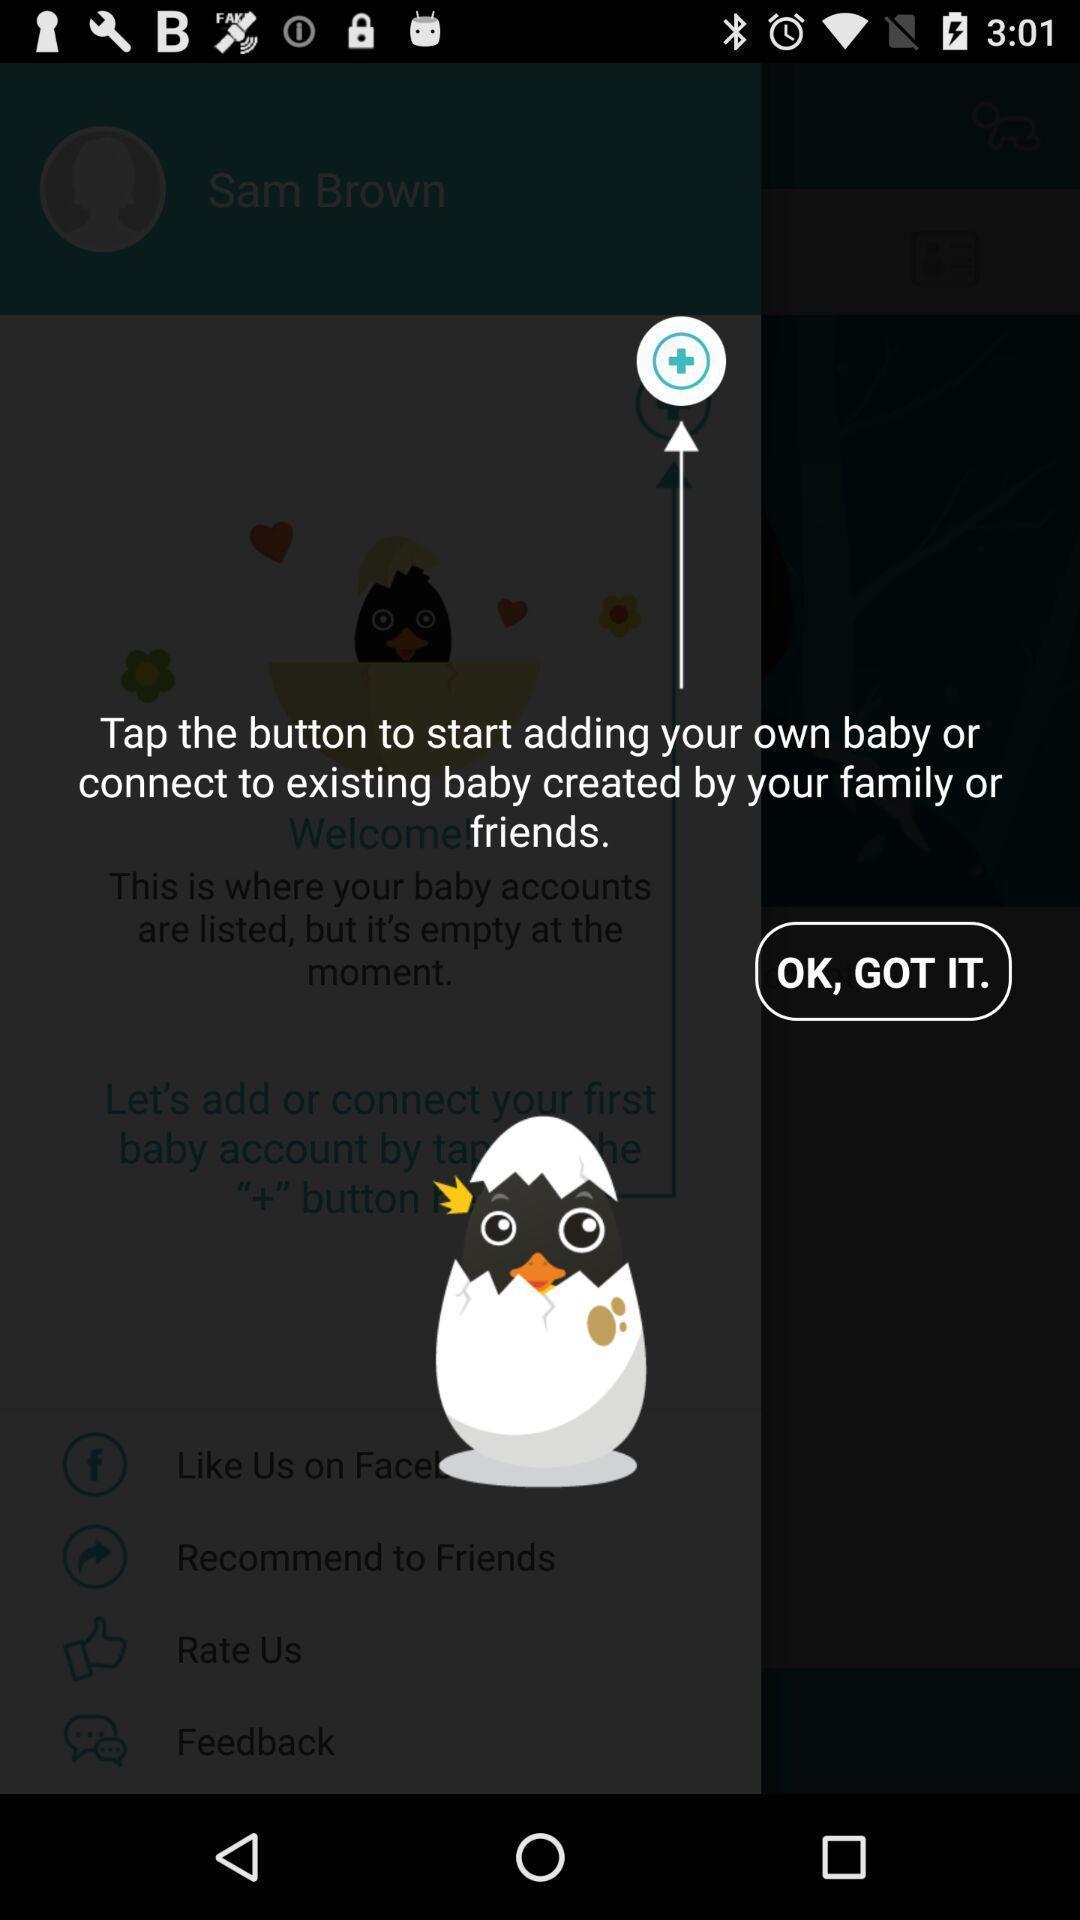What details can you identify in this image? Welcome page. 